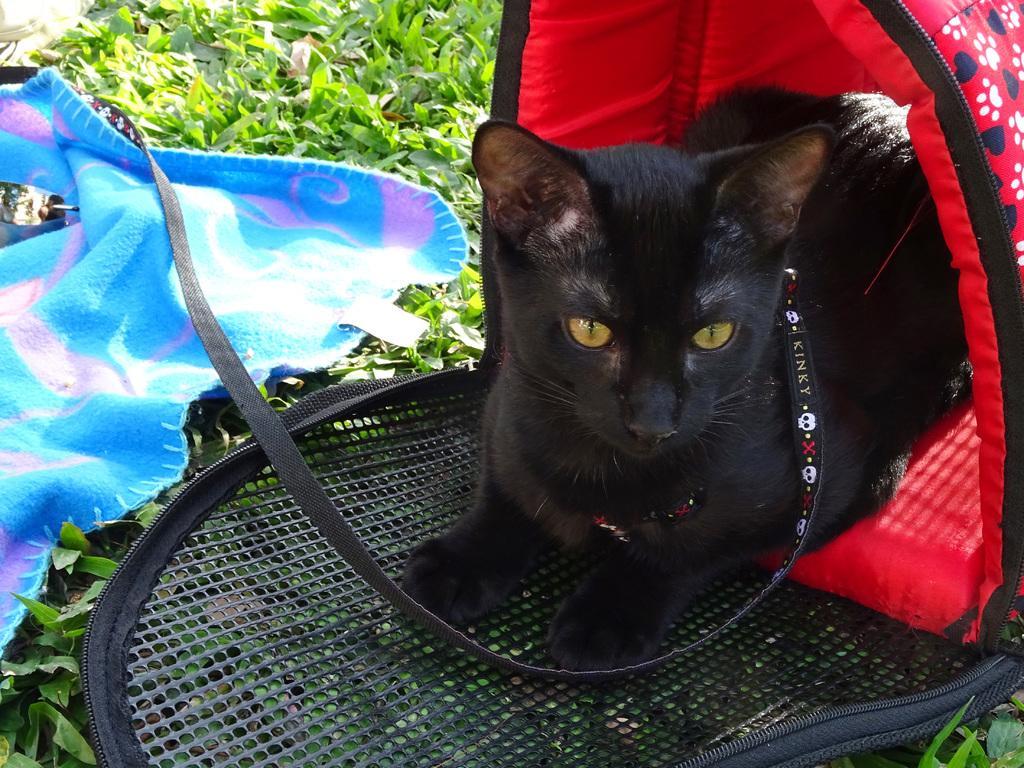How would you summarize this image in a sentence or two? In this image there is a cat sitting in a cat tent, beside the cat there is a cloth on the grass. 